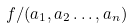<formula> <loc_0><loc_0><loc_500><loc_500>f / ( a _ { 1 } , a _ { 2 } \dots , a _ { n } )</formula> 